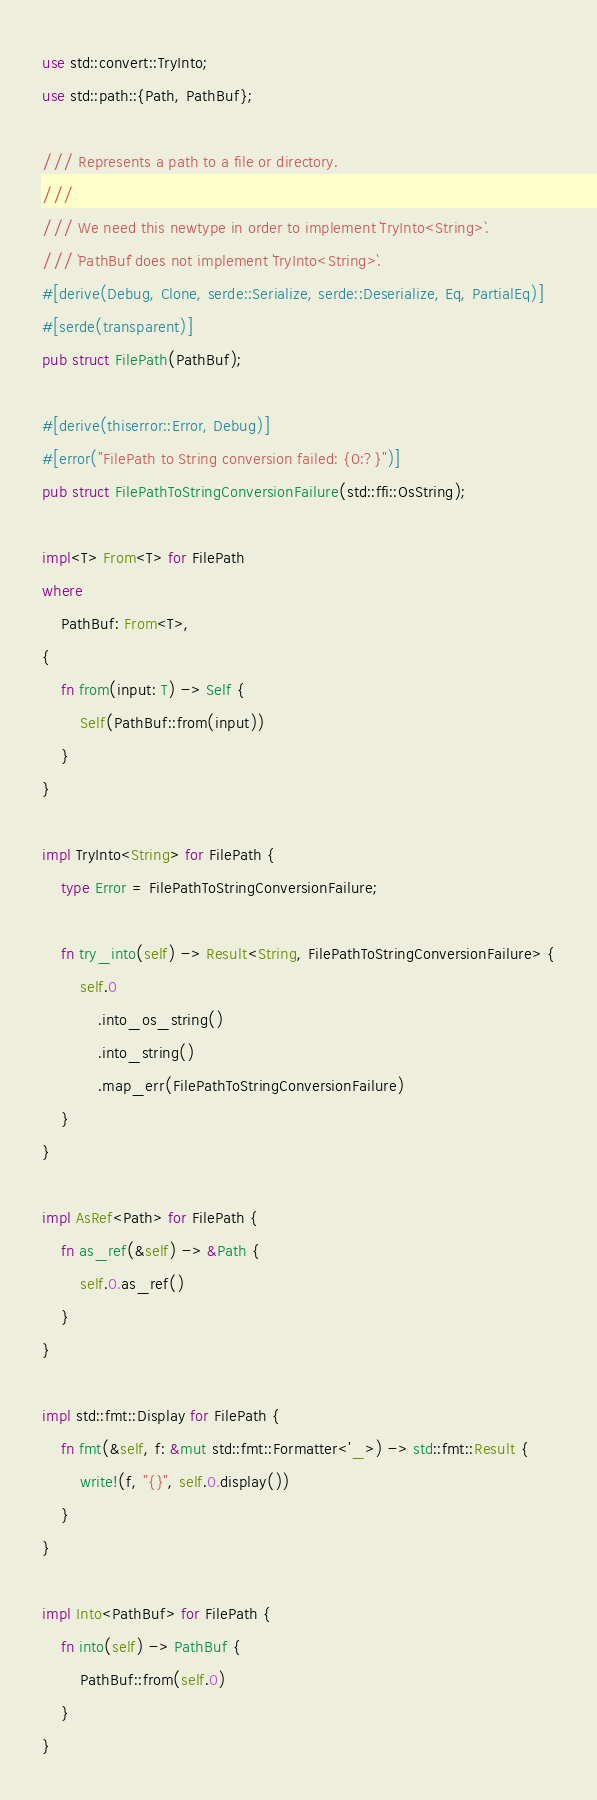<code> <loc_0><loc_0><loc_500><loc_500><_Rust_>use std::convert::TryInto;
use std::path::{Path, PathBuf};

/// Represents a path to a file or directory.
///
/// We need this newtype in order to implement `TryInto<String>`.
/// `PathBuf` does not implement `TryInto<String>`.
#[derive(Debug, Clone, serde::Serialize, serde::Deserialize, Eq, PartialEq)]
#[serde(transparent)]
pub struct FilePath(PathBuf);

#[derive(thiserror::Error, Debug)]
#[error("FilePath to String conversion failed: {0:?}")]
pub struct FilePathToStringConversionFailure(std::ffi::OsString);

impl<T> From<T> for FilePath
where
    PathBuf: From<T>,
{
    fn from(input: T) -> Self {
        Self(PathBuf::from(input))
    }
}

impl TryInto<String> for FilePath {
    type Error = FilePathToStringConversionFailure;

    fn try_into(self) -> Result<String, FilePathToStringConversionFailure> {
        self.0
            .into_os_string()
            .into_string()
            .map_err(FilePathToStringConversionFailure)
    }
}

impl AsRef<Path> for FilePath {
    fn as_ref(&self) -> &Path {
        self.0.as_ref()
    }
}

impl std::fmt::Display for FilePath {
    fn fmt(&self, f: &mut std::fmt::Formatter<'_>) -> std::fmt::Result {
        write!(f, "{}", self.0.display())
    }
}

impl Into<PathBuf> for FilePath {
    fn into(self) -> PathBuf {
        PathBuf::from(self.0)
    }
}
</code> 